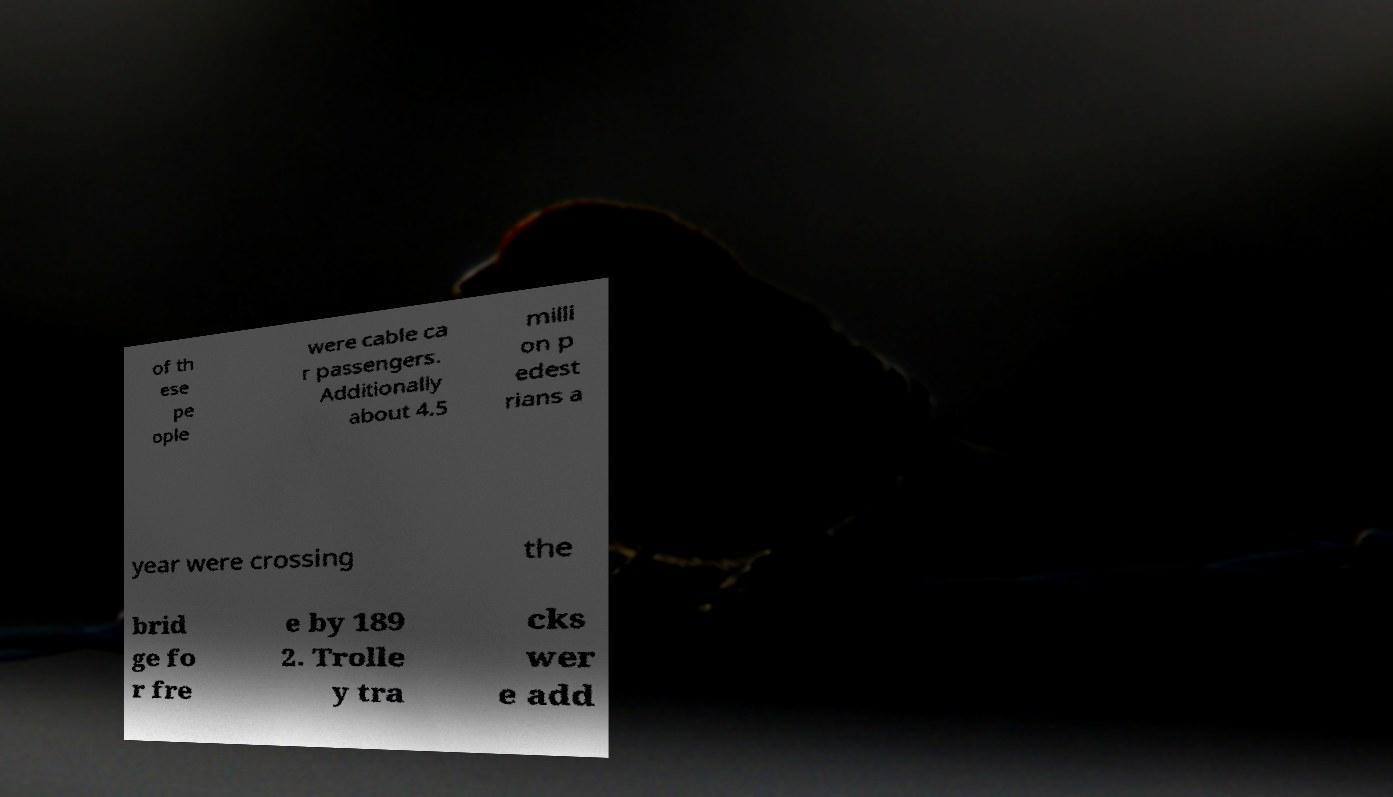I need the written content from this picture converted into text. Can you do that? of th ese pe ople were cable ca r passengers. Additionally about 4.5 milli on p edest rians a year were crossing the brid ge fo r fre e by 189 2. Trolle y tra cks wer e add 